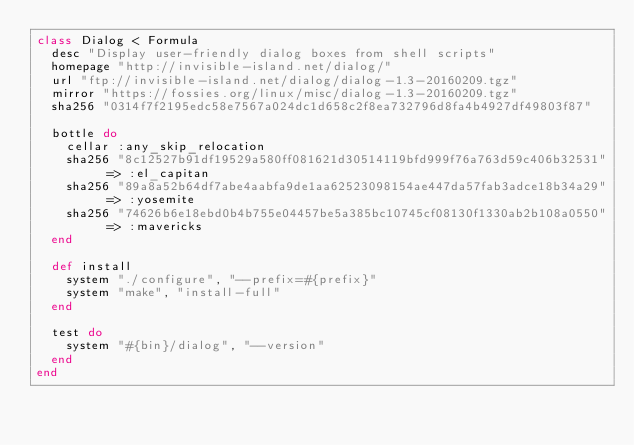Convert code to text. <code><loc_0><loc_0><loc_500><loc_500><_Ruby_>class Dialog < Formula
  desc "Display user-friendly dialog boxes from shell scripts"
  homepage "http://invisible-island.net/dialog/"
  url "ftp://invisible-island.net/dialog/dialog-1.3-20160209.tgz"
  mirror "https://fossies.org/linux/misc/dialog-1.3-20160209.tgz"
  sha256 "0314f7f2195edc58e7567a024dc1d658c2f8ea732796d8fa4b4927df49803f87"

  bottle do
    cellar :any_skip_relocation
    sha256 "8c12527b91df19529a580ff081621d30514119bfd999f76a763d59c406b32531" => :el_capitan
    sha256 "89a8a52b64df7abe4aabfa9de1aa62523098154ae447da57fab3adce18b34a29" => :yosemite
    sha256 "74626b6e18ebd0b4b755e04457be5a385bc10745cf08130f1330ab2b108a0550" => :mavericks
  end

  def install
    system "./configure", "--prefix=#{prefix}"
    system "make", "install-full"
  end

  test do
    system "#{bin}/dialog", "--version"
  end
end
</code> 